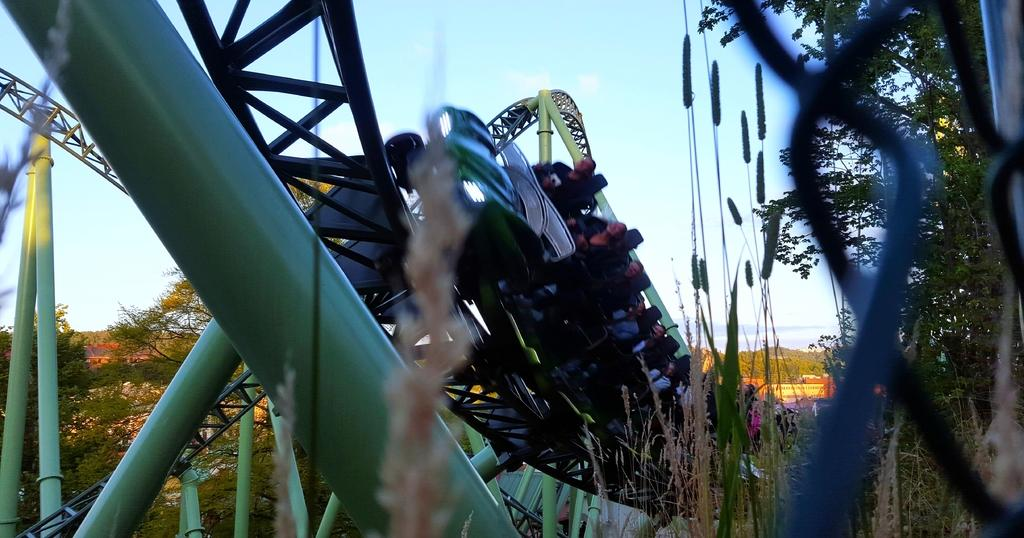What is the main subject of the image? The main subject of the image is a roller coaster. What feature of the roller coaster is mentioned in the facts? The roller coaster has tracks. What can be seen on the right side of the image? There are trees on the right side of the image. What else is visible in the background of the image? There are trees and plants in the background of the image. Can you provide a list of all the kittens in the image? There are no kittens present in the image. What type of picture is the roller coaster in? The facts provided do not specify the type of picture or image, only the contents of the image. 